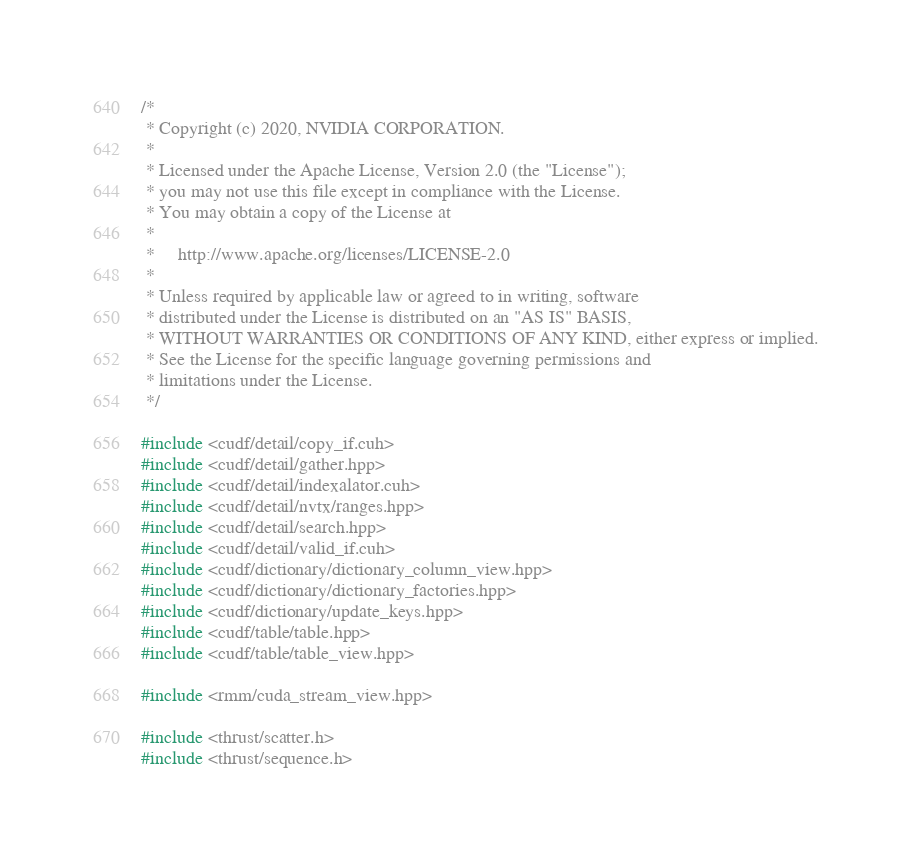Convert code to text. <code><loc_0><loc_0><loc_500><loc_500><_Cuda_>/*
 * Copyright (c) 2020, NVIDIA CORPORATION.
 *
 * Licensed under the Apache License, Version 2.0 (the "License");
 * you may not use this file except in compliance with the License.
 * You may obtain a copy of the License at
 *
 *     http://www.apache.org/licenses/LICENSE-2.0
 *
 * Unless required by applicable law or agreed to in writing, software
 * distributed under the License is distributed on an "AS IS" BASIS,
 * WITHOUT WARRANTIES OR CONDITIONS OF ANY KIND, either express or implied.
 * See the License for the specific language governing permissions and
 * limitations under the License.
 */

#include <cudf/detail/copy_if.cuh>
#include <cudf/detail/gather.hpp>
#include <cudf/detail/indexalator.cuh>
#include <cudf/detail/nvtx/ranges.hpp>
#include <cudf/detail/search.hpp>
#include <cudf/detail/valid_if.cuh>
#include <cudf/dictionary/dictionary_column_view.hpp>
#include <cudf/dictionary/dictionary_factories.hpp>
#include <cudf/dictionary/update_keys.hpp>
#include <cudf/table/table.hpp>
#include <cudf/table/table_view.hpp>

#include <rmm/cuda_stream_view.hpp>

#include <thrust/scatter.h>
#include <thrust/sequence.h></code> 